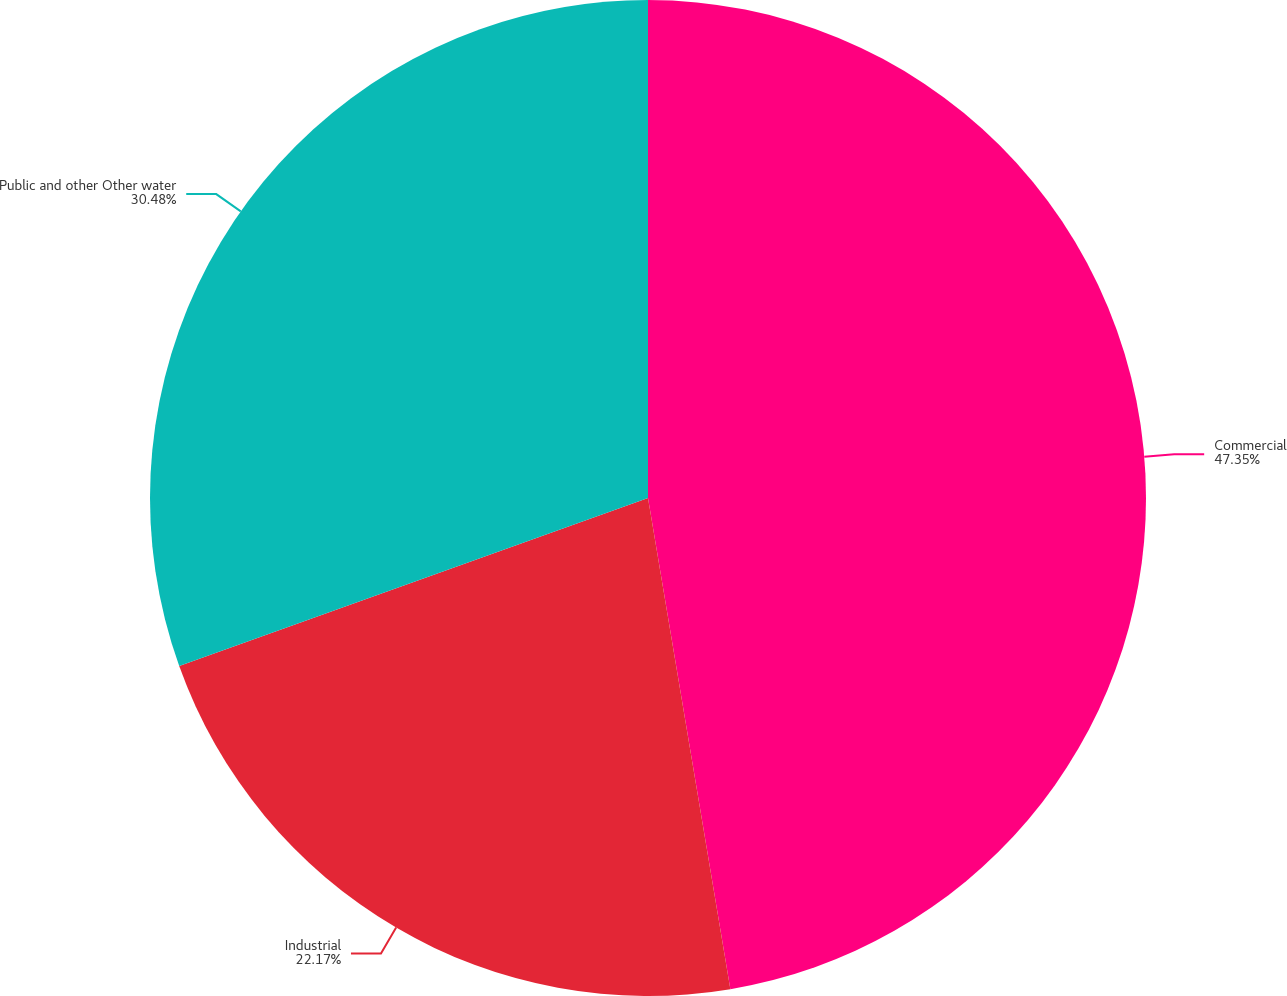<chart> <loc_0><loc_0><loc_500><loc_500><pie_chart><fcel>Commercial<fcel>Industrial<fcel>Public and other Other water<nl><fcel>47.36%<fcel>22.17%<fcel>30.48%<nl></chart> 